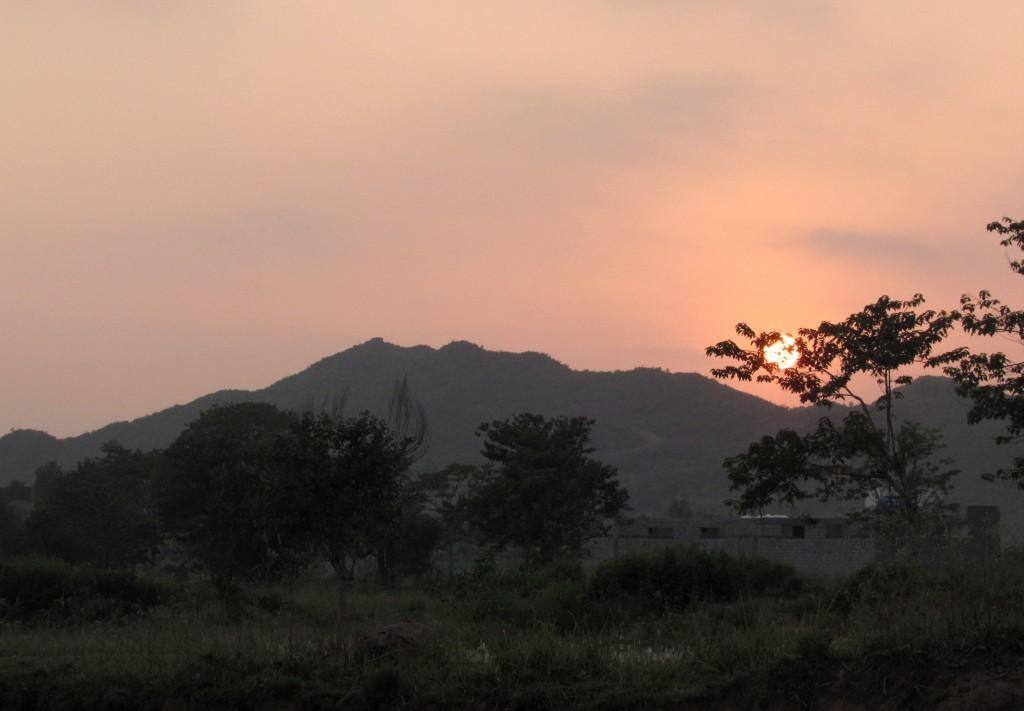What type of vegetation can be seen in the image? There are trees in the image. What type of structure is visible in the image? There is a house in the image. What can be seen in the distance in the image? There are mountains in the background of the background of the image. What is visible at the top of the image? The sky is visible at the top of the image. What celestial body can be seen in the sky? The sun is observable in the sky. Where is the dock located in the image? There is no dock present in the image. What type of property is visible in the image? The image does not show any specific property; it features trees, a house, mountains, and the sky. 